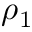<formula> <loc_0><loc_0><loc_500><loc_500>\rho _ { 1 }</formula> 